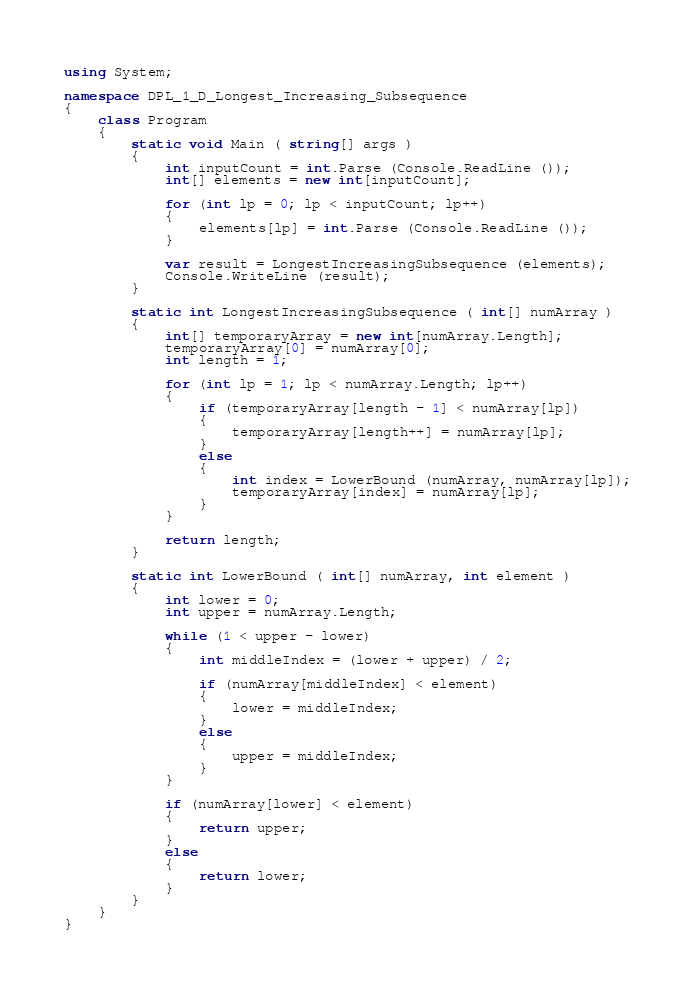<code> <loc_0><loc_0><loc_500><loc_500><_C#_>using System;

namespace DPL_1_D_Longest_Increasing_Subsequence
{
	class Program
	{
		static void Main ( string[] args )
		{
			int inputCount = int.Parse (Console.ReadLine ());
			int[] elements = new int[inputCount];

			for (int lp = 0; lp < inputCount; lp++)
			{
				elements[lp] = int.Parse (Console.ReadLine ());
			}

			var result = LongestIncreasingSubsequence (elements);
			Console.WriteLine (result);
		}

		static int LongestIncreasingSubsequence ( int[] numArray )
		{
			int[] temporaryArray = new int[numArray.Length];
			temporaryArray[0] = numArray[0];
			int length = 1;

			for (int lp = 1; lp < numArray.Length; lp++)
			{
				if (temporaryArray[length - 1] < numArray[lp])
				{
					temporaryArray[length++] = numArray[lp];
				}
				else
				{
					int index = LowerBound (numArray, numArray[lp]);
					temporaryArray[index] = numArray[lp];
				}
			}

			return length;
		}

		static int LowerBound ( int[] numArray, int element )
		{
			int lower = 0;
			int upper = numArray.Length;

			while (1 < upper - lower)
			{
				int middleIndex = (lower + upper) / 2;

				if (numArray[middleIndex] < element)
				{
					lower = middleIndex;
				}
				else
				{
					upper = middleIndex;
				}
			}

			if (numArray[lower] < element)
			{
				return upper;
			}
			else
			{
				return lower;
			}
		}
	}
}

</code> 